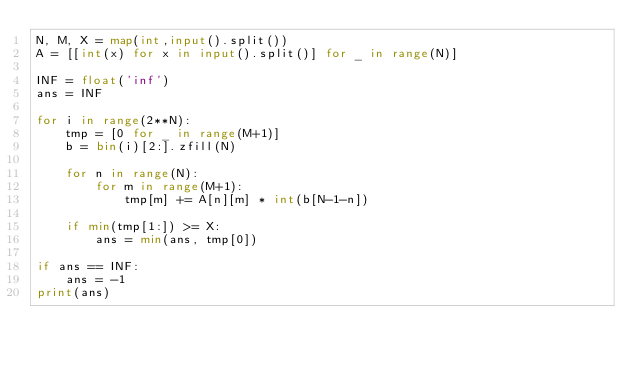<code> <loc_0><loc_0><loc_500><loc_500><_Python_>N, M, X = map(int,input().split())
A = [[int(x) for x in input().split()] for _ in range(N)]

INF = float('inf')
ans = INF

for i in range(2**N):
    tmp = [0 for _ in range(M+1)]
    b = bin(i)[2:].zfill(N)
    
    for n in range(N):
        for m in range(M+1):
            tmp[m] += A[n][m] * int(b[N-1-n])

    if min(tmp[1:]) >= X:
        ans = min(ans, tmp[0])

if ans == INF:
    ans = -1
print(ans)</code> 